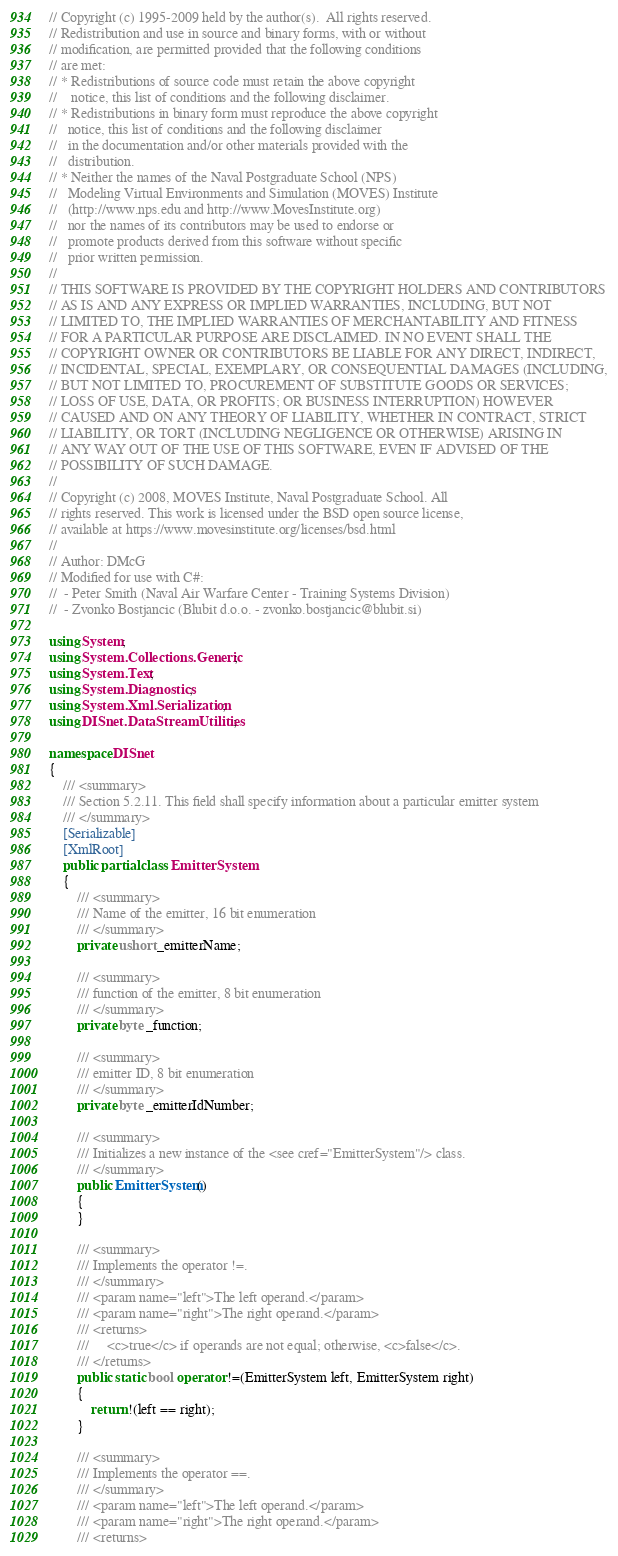<code> <loc_0><loc_0><loc_500><loc_500><_C#_>// Copyright (c) 1995-2009 held by the author(s).  All rights reserved.
// Redistribution and use in source and binary forms, with or without
// modification, are permitted provided that the following conditions
// are met:
// * Redistributions of source code must retain the above copyright
//    notice, this list of conditions and the following disclaimer.
// * Redistributions in binary form must reproduce the above copyright
//   notice, this list of conditions and the following disclaimer
//   in the documentation and/or other materials provided with the
//   distribution.
// * Neither the names of the Naval Postgraduate School (NPS)
//   Modeling Virtual Environments and Simulation (MOVES) Institute
//   (http://www.nps.edu and http://www.MovesInstitute.org)
//   nor the names of its contributors may be used to endorse or
//   promote products derived from this software without specific
//   prior written permission.
// 
// THIS SOFTWARE IS PROVIDED BY THE COPYRIGHT HOLDERS AND CONTRIBUTORS
// AS IS AND ANY EXPRESS OR IMPLIED WARRANTIES, INCLUDING, BUT NOT
// LIMITED TO, THE IMPLIED WARRANTIES OF MERCHANTABILITY AND FITNESS
// FOR A PARTICULAR PURPOSE ARE DISCLAIMED. IN NO EVENT SHALL THE
// COPYRIGHT OWNER OR CONTRIBUTORS BE LIABLE FOR ANY DIRECT, INDIRECT,
// INCIDENTAL, SPECIAL, EXEMPLARY, OR CONSEQUENTIAL DAMAGES (INCLUDING,
// BUT NOT LIMITED TO, PROCUREMENT OF SUBSTITUTE GOODS OR SERVICES;
// LOSS OF USE, DATA, OR PROFITS; OR BUSINESS INTERRUPTION) HOWEVER
// CAUSED AND ON ANY THEORY OF LIABILITY, WHETHER IN CONTRACT, STRICT
// LIABILITY, OR TORT (INCLUDING NEGLIGENCE OR OTHERWISE) ARISING IN
// ANY WAY OUT OF THE USE OF THIS SOFTWARE, EVEN IF ADVISED OF THE
// POSSIBILITY OF SUCH DAMAGE.
//
// Copyright (c) 2008, MOVES Institute, Naval Postgraduate School. All 
// rights reserved. This work is licensed under the BSD open source license,
// available at https://www.movesinstitute.org/licenses/bsd.html
//
// Author: DMcG
// Modified for use with C#:
//  - Peter Smith (Naval Air Warfare Center - Training Systems Division)
//  - Zvonko Bostjancic (Blubit d.o.o. - zvonko.bostjancic@blubit.si)

using System;
using System.Collections.Generic;
using System.Text;
using System.Diagnostics;
using System.Xml.Serialization;
using DISnet.DataStreamUtilities;

namespace DISnet
{
    /// <summary>
    /// Section 5.2.11. This field shall specify information about a particular emitter system
    /// </summary>
    [Serializable]
    [XmlRoot]
    public partial class EmitterSystem
    {
        /// <summary>
        /// Name of the emitter, 16 bit enumeration
        /// </summary>
        private ushort _emitterName;

        /// <summary>
        /// function of the emitter, 8 bit enumeration
        /// </summary>
        private byte _function;

        /// <summary>
        /// emitter ID, 8 bit enumeration
        /// </summary>
        private byte _emitterIdNumber;

        /// <summary>
        /// Initializes a new instance of the <see cref="EmitterSystem"/> class.
        /// </summary>
        public EmitterSystem()
        {
        }

        /// <summary>
        /// Implements the operator !=.
        /// </summary>
        /// <param name="left">The left operand.</param>
        /// <param name="right">The right operand.</param>
        /// <returns>
        /// 	<c>true</c> if operands are not equal; otherwise, <c>false</c>.
        /// </returns>
        public static bool operator !=(EmitterSystem left, EmitterSystem right)
        {
            return !(left == right);
        }

        /// <summary>
        /// Implements the operator ==.
        /// </summary>
        /// <param name="left">The left operand.</param>
        /// <param name="right">The right operand.</param>
        /// <returns></code> 